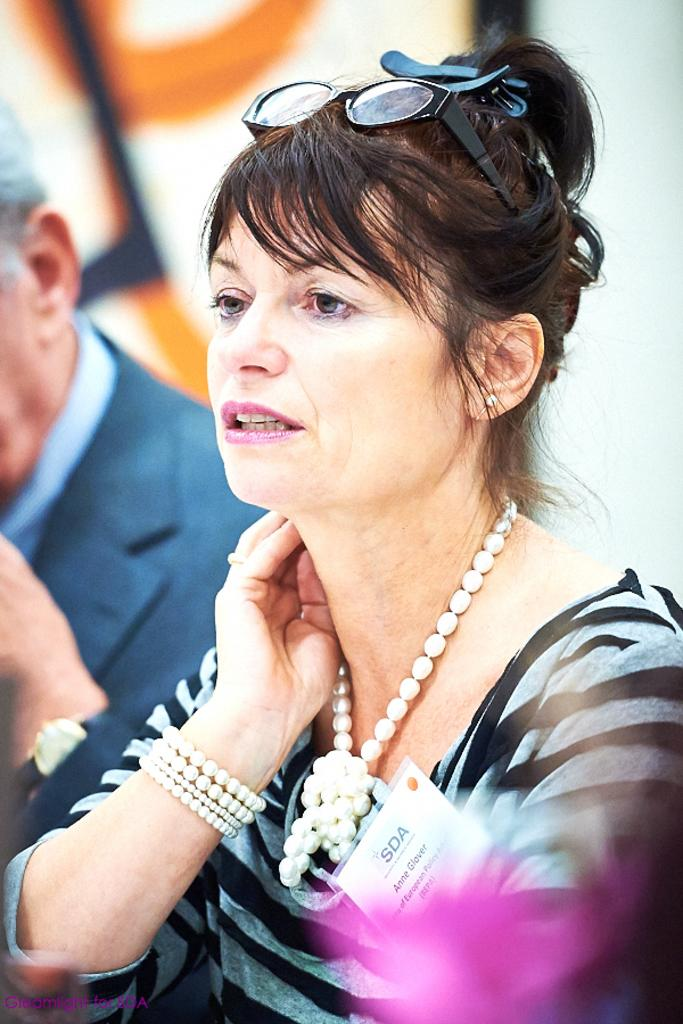Who is present in the image? There is a woman in the image. What is the woman doing in the image? The woman is sitting in the image. Which direction is the woman looking in the image? The woman is watching towards the left in the image. What type of accessories is the woman wearing in the image? The woman is wearing pearl accessories in the image. Can you describe any additional details about the woman in the image? The woman has a tag with some text on it in the image. What is the woman teaching in the image? There is no indication in the image that the woman is teaching anything. 